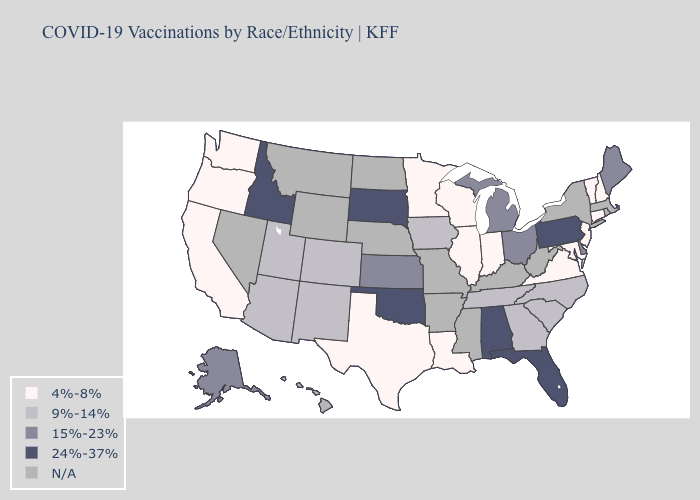Does Washington have the lowest value in the USA?
Give a very brief answer. Yes. What is the lowest value in states that border Texas?
Give a very brief answer. 4%-8%. Does the first symbol in the legend represent the smallest category?
Write a very short answer. Yes. What is the highest value in the West ?
Quick response, please. 24%-37%. What is the value of Idaho?
Write a very short answer. 24%-37%. Does Connecticut have the lowest value in the USA?
Answer briefly. Yes. What is the highest value in the Northeast ?
Be succinct. 24%-37%. Name the states that have a value in the range 24%-37%?
Be succinct. Alabama, Florida, Idaho, Oklahoma, Pennsylvania, South Dakota. Name the states that have a value in the range 4%-8%?
Give a very brief answer. California, Connecticut, Illinois, Indiana, Louisiana, Maryland, Minnesota, New Hampshire, New Jersey, Oregon, Texas, Vermont, Virginia, Washington, Wisconsin. How many symbols are there in the legend?
Quick response, please. 5. Name the states that have a value in the range 24%-37%?
Short answer required. Alabama, Florida, Idaho, Oklahoma, Pennsylvania, South Dakota. Name the states that have a value in the range 4%-8%?
Quick response, please. California, Connecticut, Illinois, Indiana, Louisiana, Maryland, Minnesota, New Hampshire, New Jersey, Oregon, Texas, Vermont, Virginia, Washington, Wisconsin. What is the highest value in the USA?
Concise answer only. 24%-37%. What is the lowest value in the South?
Quick response, please. 4%-8%. 